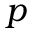<formula> <loc_0><loc_0><loc_500><loc_500>p</formula> 